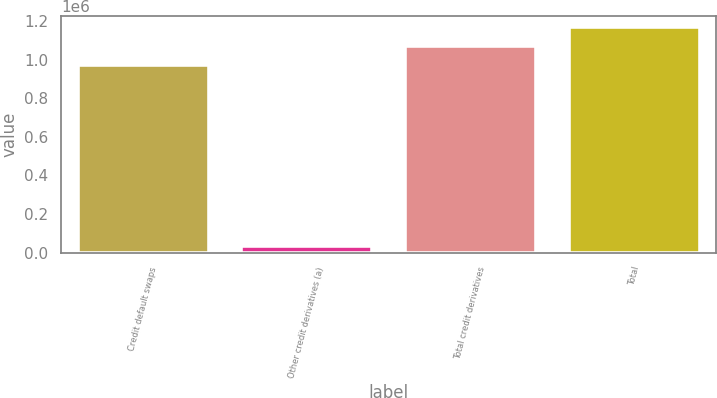<chart> <loc_0><loc_0><loc_500><loc_500><bar_chart><fcel>Credit default swaps<fcel>Other credit derivatives (a)<fcel>Total credit derivatives<fcel>Total<nl><fcel>974252<fcel>31859<fcel>1.07168e+06<fcel>1.1691e+06<nl></chart> 